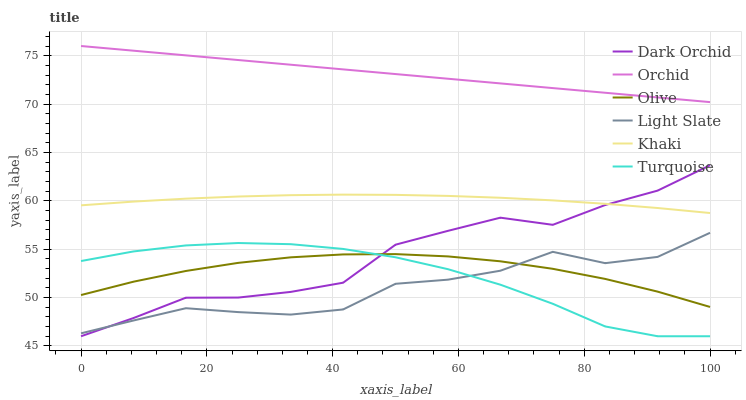Does Light Slate have the minimum area under the curve?
Answer yes or no. Yes. Does Khaki have the minimum area under the curve?
Answer yes or no. No. Does Khaki have the maximum area under the curve?
Answer yes or no. No. Is Dark Orchid the roughest?
Answer yes or no. Yes. Is Khaki the smoothest?
Answer yes or no. No. Is Khaki the roughest?
Answer yes or no. No. Does Khaki have the lowest value?
Answer yes or no. No. Does Khaki have the highest value?
Answer yes or no. No. Is Khaki less than Orchid?
Answer yes or no. Yes. Is Orchid greater than Olive?
Answer yes or no. Yes. Does Khaki intersect Orchid?
Answer yes or no. No. 